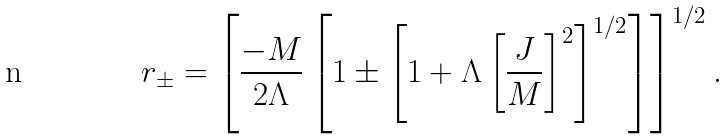Convert formula to latex. <formula><loc_0><loc_0><loc_500><loc_500>r _ { \pm } = \left [ \frac { - M } { 2 \Lambda } \left [ 1 \pm \left [ 1 + \Lambda \left [ \frac { J } { M } \right ] ^ { 2 } \right ] ^ { 1 / 2 } \right ] \right ] ^ { 1 / 2 } .</formula> 